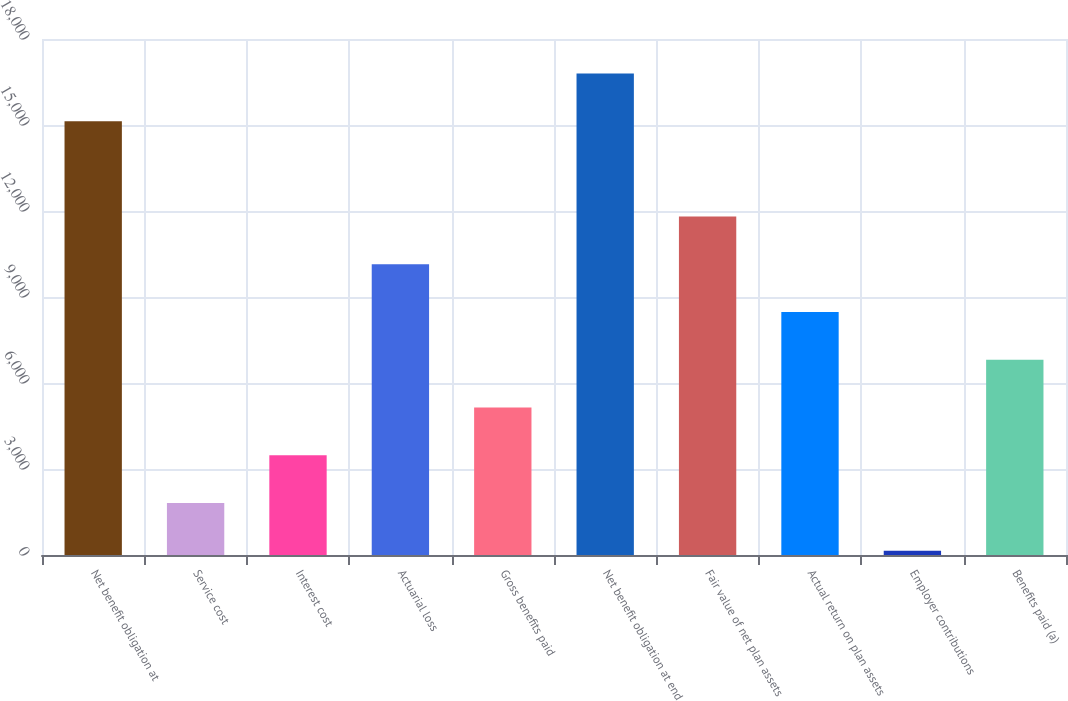Convert chart. <chart><loc_0><loc_0><loc_500><loc_500><bar_chart><fcel>Net benefit obligation at<fcel>Service cost<fcel>Interest cost<fcel>Actuarial loss<fcel>Gross benefits paid<fcel>Net benefit obligation at end<fcel>Fair value of net plan assets<fcel>Actual return on plan assets<fcel>Employer contributions<fcel>Benefits paid (a)<nl><fcel>15134.9<fcel>1814.1<fcel>3479.2<fcel>10139.6<fcel>5144.3<fcel>16800<fcel>11804.7<fcel>8474.5<fcel>149<fcel>6809.4<nl></chart> 